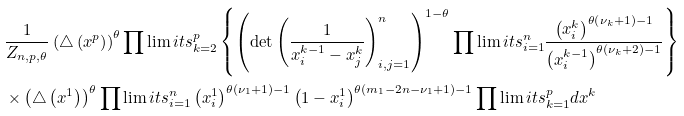<formula> <loc_0><loc_0><loc_500><loc_500>& \frac { 1 } { Z _ { n , p , \theta } } \left ( \triangle \left ( x ^ { p } \right ) \right ) ^ { \theta } \prod \lim i t s _ { k = 2 } ^ { p } \left \{ \left ( \det \left ( \frac { 1 } { x _ { i } ^ { k - 1 } - x _ { j } ^ { k } } \right ) _ { i , j = 1 } ^ { n } \right ) ^ { 1 - \theta } \prod \lim i t s _ { i = 1 } ^ { n } \frac { \left ( x _ { i } ^ { k } \right ) ^ { \theta \left ( \nu _ { k } + 1 \right ) - 1 } } { \left ( x _ { i } ^ { k - 1 } \right ) ^ { \theta \left ( \nu _ { k } + 2 \right ) - 1 } } \right \} \\ & \times \left ( \triangle \left ( x ^ { 1 } \right ) \right ) ^ { \theta } \prod \lim i t s _ { i = 1 } ^ { n } \left ( x _ { i } ^ { 1 } \right ) ^ { \theta \left ( \nu _ { 1 } + 1 \right ) - 1 } \left ( 1 - x _ { i } ^ { 1 } \right ) ^ { \theta \left ( m _ { 1 } - 2 n - \nu _ { 1 } + 1 \right ) - 1 } \prod \lim i t s _ { k = 1 } ^ { p } d x ^ { k }</formula> 